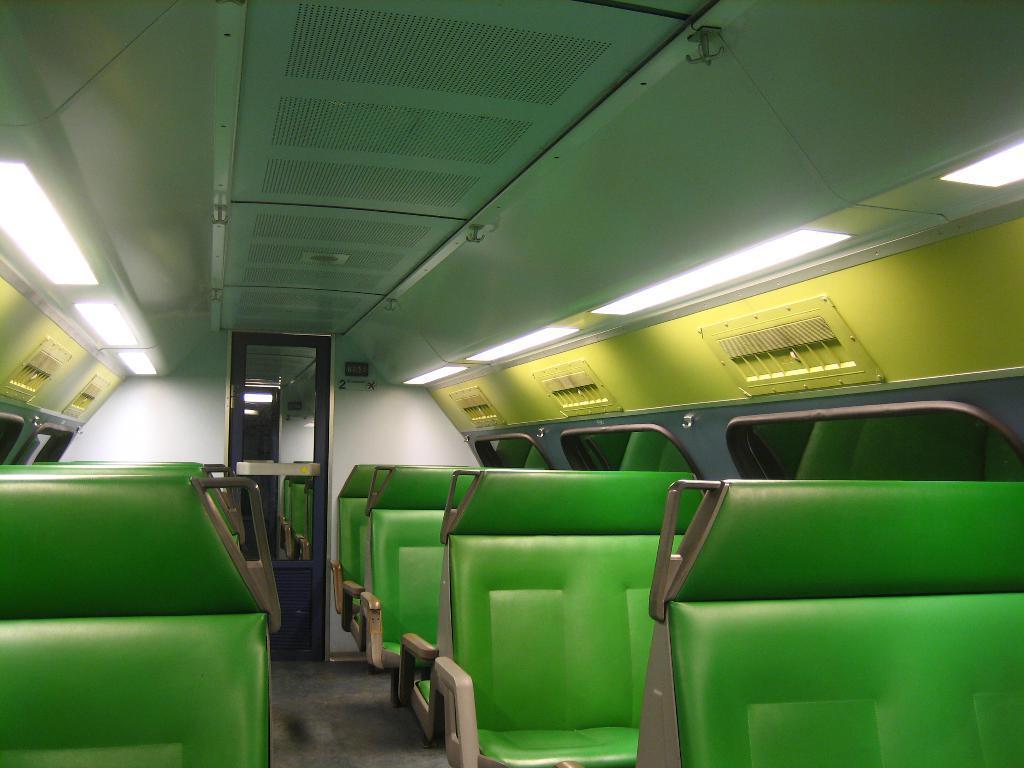How would you summarize this image in a sentence or two? In this image I can see there are green color seats and at the top there are lights to the ceiling. It is an inside part of a vehicle. 